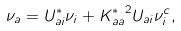Convert formula to latex. <formula><loc_0><loc_0><loc_500><loc_500>\nu _ { a } = U _ { a i } ^ { \ast } \nu _ { i } + { K _ { a a } ^ { \ast } } ^ { 2 } U _ { a i } \nu _ { i } ^ { c } ,</formula> 